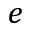<formula> <loc_0><loc_0><loc_500><loc_500>e</formula> 